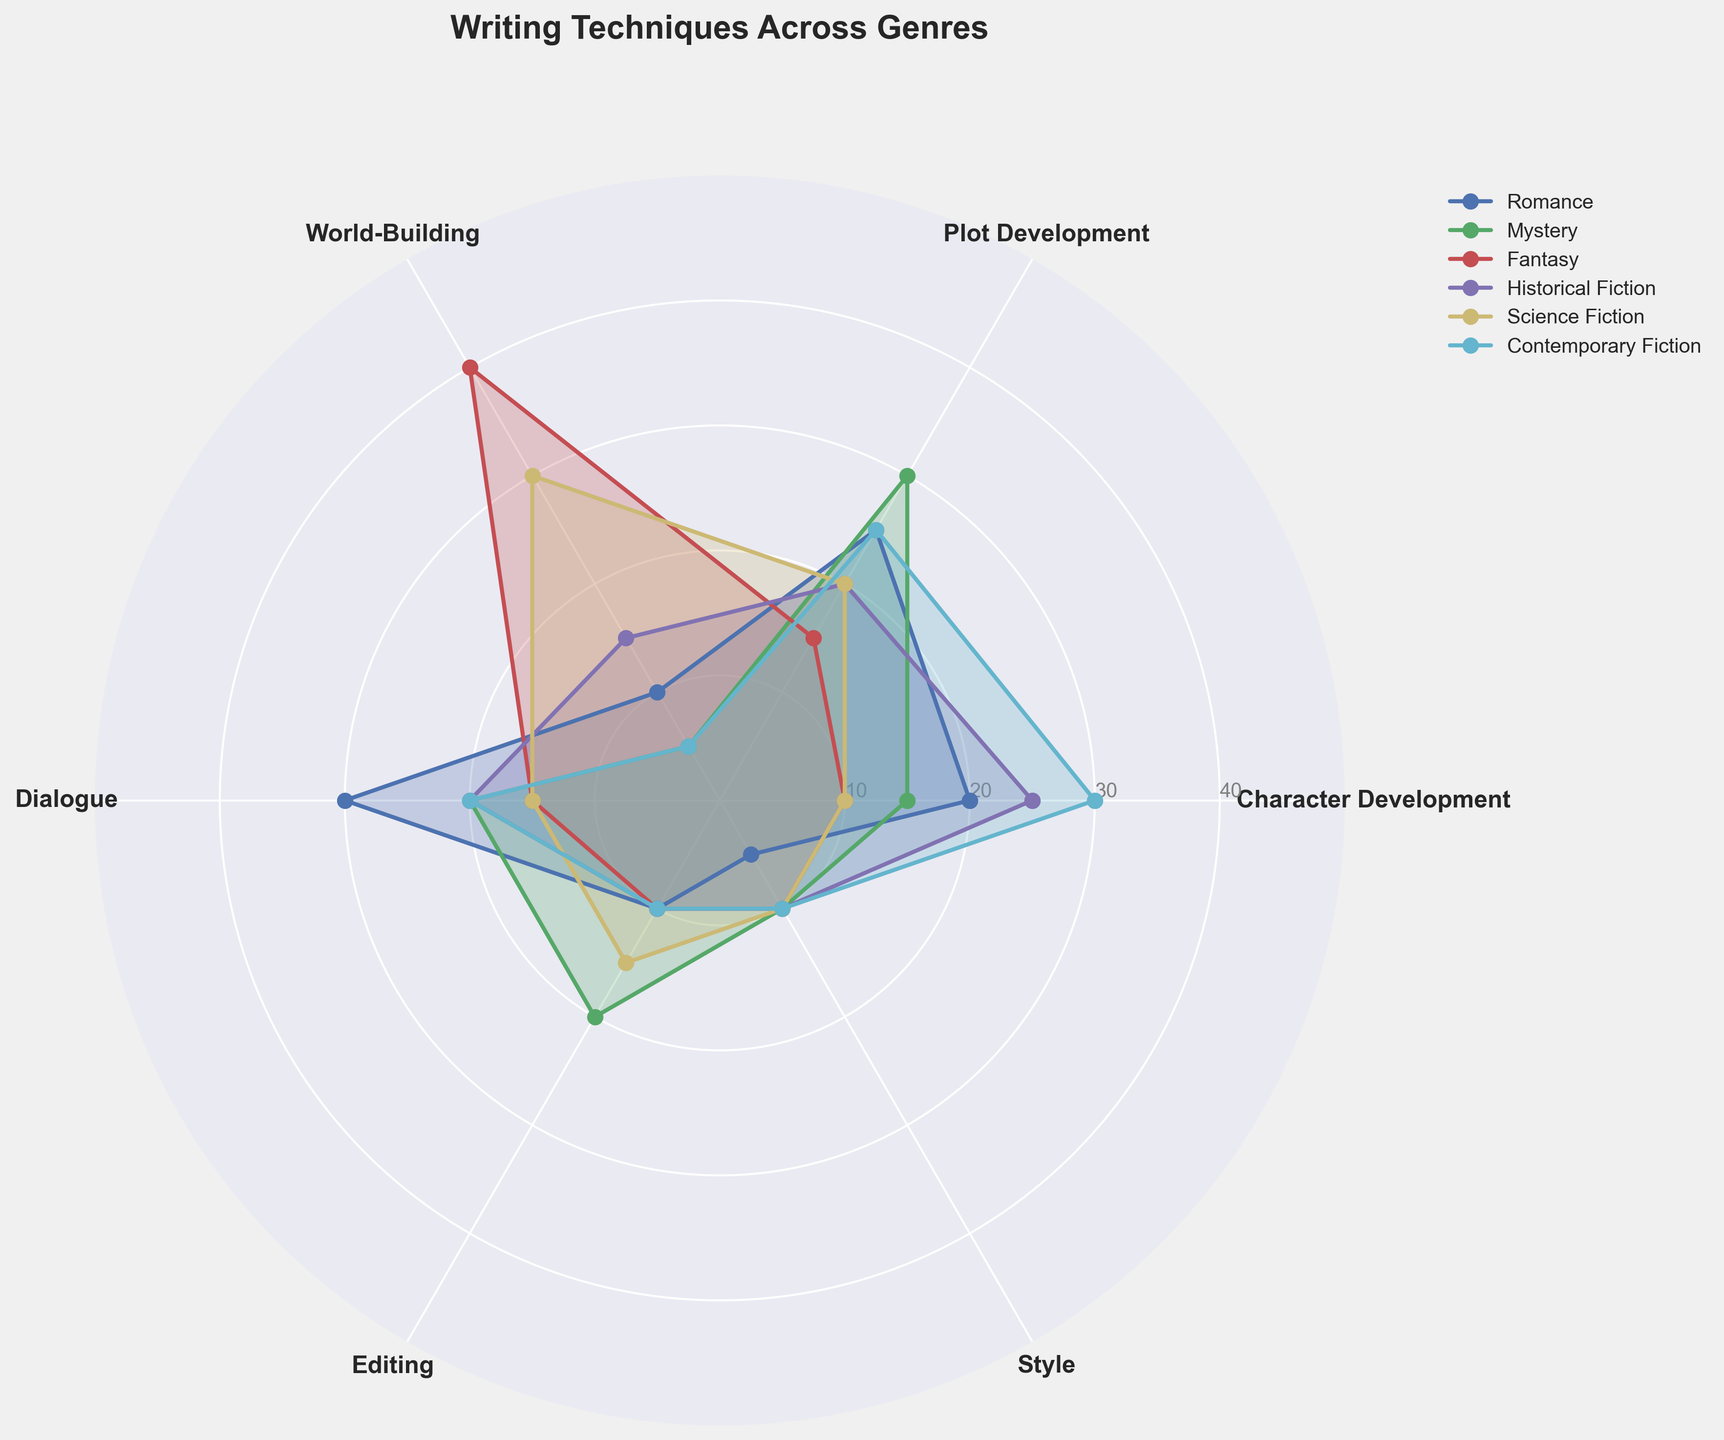What is the title of the chart? The title is usually placed at the top of the chart in bold. In this chart, it clearly states the purpose of the visualization.
Answer: Writing Techniques Across Genres How many genres are represented in the chart? The chart has multiple colored areas, each representing a different genre. By counting these distinct areas in the legend, we get the total number of genres.
Answer: Six Which genre has the highest value for character development? By examining the radial axis corresponding to 'Character Development' and comparing the lines, the genre with the largest extent from the center at that axis stands out.
Answer: Contemporary Fiction What are the different categories of writing techniques shown in the chart? Looking at the labels on the angular axes, all the different categories are listed around the chart's circumference.
Answer: Character Development, Plot Development, World-Building, Dialogue, Editing, Style Which genre has the lowest value in world-building? By examining the radial axis corresponding to 'World-Building,' the genre whose line has the smallest extent from the center at that axis is found.
Answer: Mystery and Contemporary Fiction (tie) Which two genres have the most similar profiles for editing? Observing and comparing the extent of the lines directly on the 'Editing' axis makes it clear which two genres have similar lengths at this point.
Answer: Mystery and Science Fiction Which genre has the greatest diversity in values across the categories? Look at the spread or variability of each genre's line across all the categories. The genre with the largest variation in distances from the center has the greatest diversity.
Answer: Science Fiction What is the average value of plot development across all genres? Add up all the values for 'Plot Development' for each genre and then divide by the number of genres: (25+30+15+20+20+25) / 6 = 135 / 6 = 22.5
Answer: 22.5 Which genre shows the most balanced use of all writing techniques? The genre with lines that are relatively equidistant from the center across all categories indicates a balanced approach.
Answer: Historical Fiction For which genre does dialogue take the highest proportion compared to other techniques? By looking at the lengths of the lines corresponding to 'Dialogue' and comparing them to other categories within the same genre, we identify the genre where 'Dialogue' is proportionally the largest.
Answer: Romance 